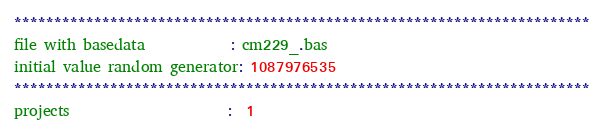Convert code to text. <code><loc_0><loc_0><loc_500><loc_500><_ObjectiveC_>************************************************************************
file with basedata            : cm229_.bas
initial value random generator: 1087976535
************************************************************************
projects                      :  1</code> 